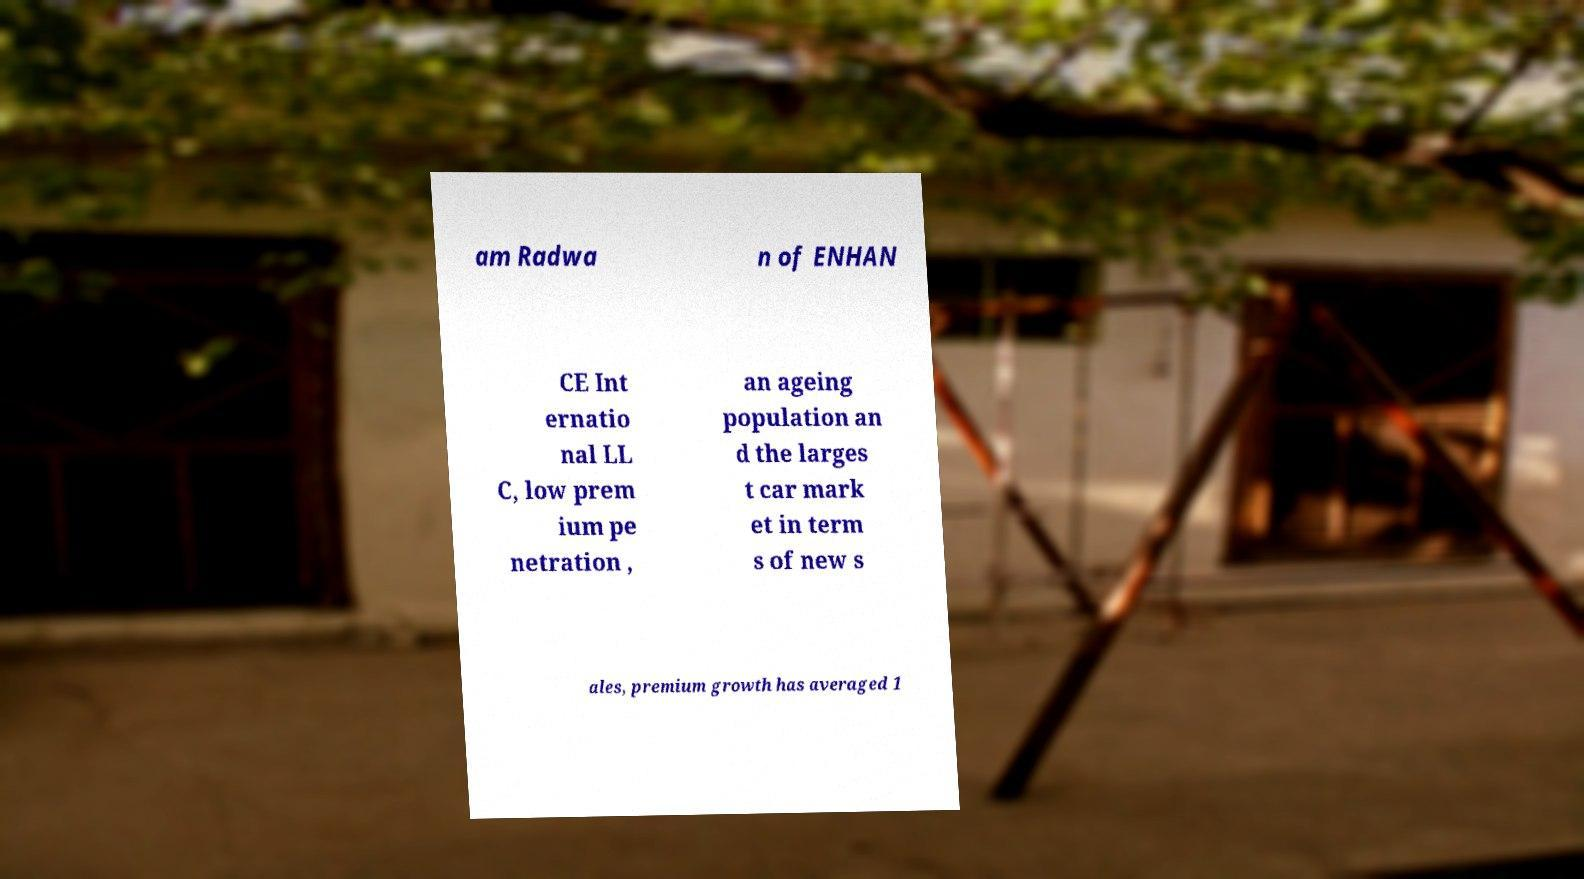There's text embedded in this image that I need extracted. Can you transcribe it verbatim? am Radwa n of ENHAN CE Int ernatio nal LL C, low prem ium pe netration , an ageing population an d the larges t car mark et in term s of new s ales, premium growth has averaged 1 